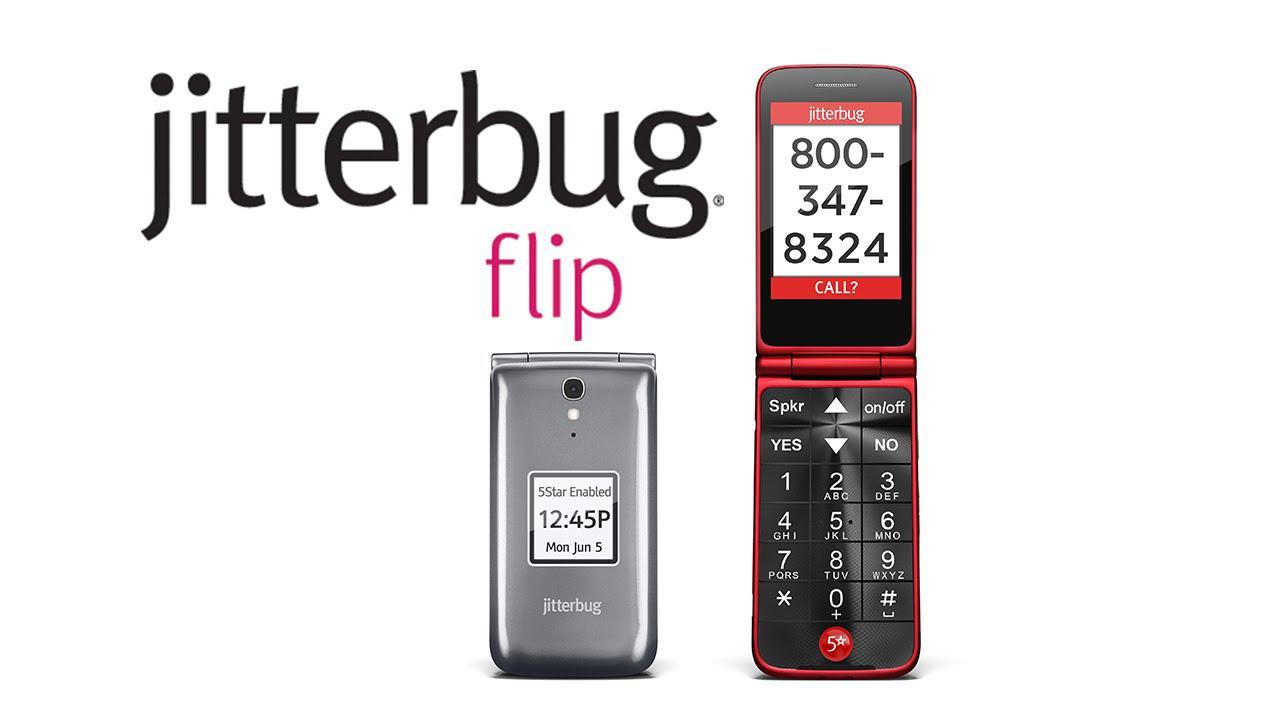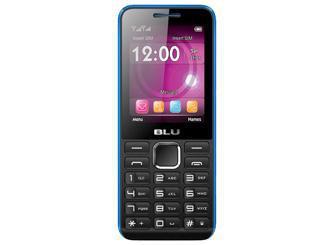The first image is the image on the left, the second image is the image on the right. Analyze the images presented: Is the assertion "One image shows a head-on open flip phone next to a closed phone, and the other image shows a single phone displayed upright and headon." valid? Answer yes or no. Yes. The first image is the image on the left, the second image is the image on the right. For the images shown, is this caption "Each phone is the same model" true? Answer yes or no. No. 